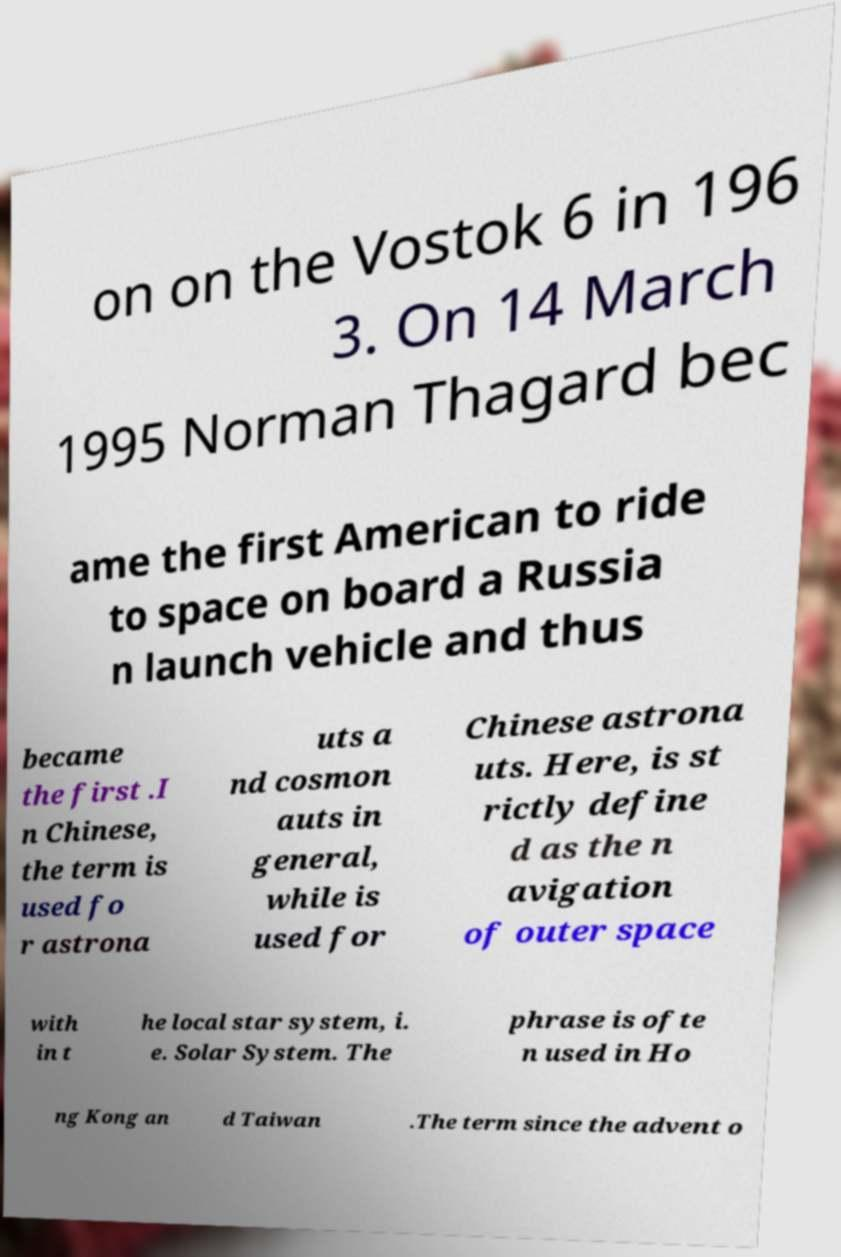I need the written content from this picture converted into text. Can you do that? on on the Vostok 6 in 196 3. On 14 March 1995 Norman Thagard bec ame the first American to ride to space on board a Russia n launch vehicle and thus became the first .I n Chinese, the term is used fo r astrona uts a nd cosmon auts in general, while is used for Chinese astrona uts. Here, is st rictly define d as the n avigation of outer space with in t he local star system, i. e. Solar System. The phrase is ofte n used in Ho ng Kong an d Taiwan .The term since the advent o 